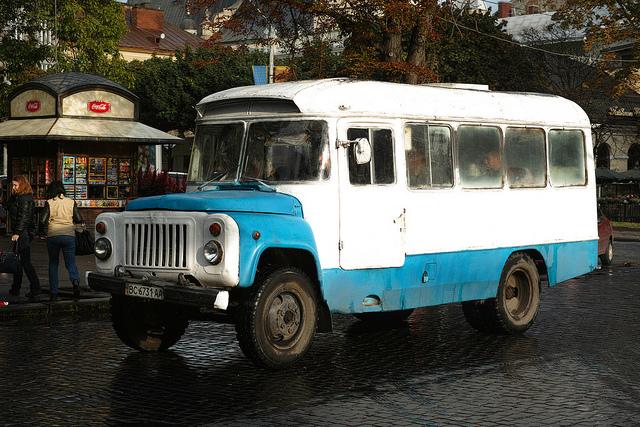What color is the rust on the wheels?
Answer briefly. Brown. What is the bus driving on?
Keep it brief. Road. What type of vehicle is this?
Answer briefly. Bus. 